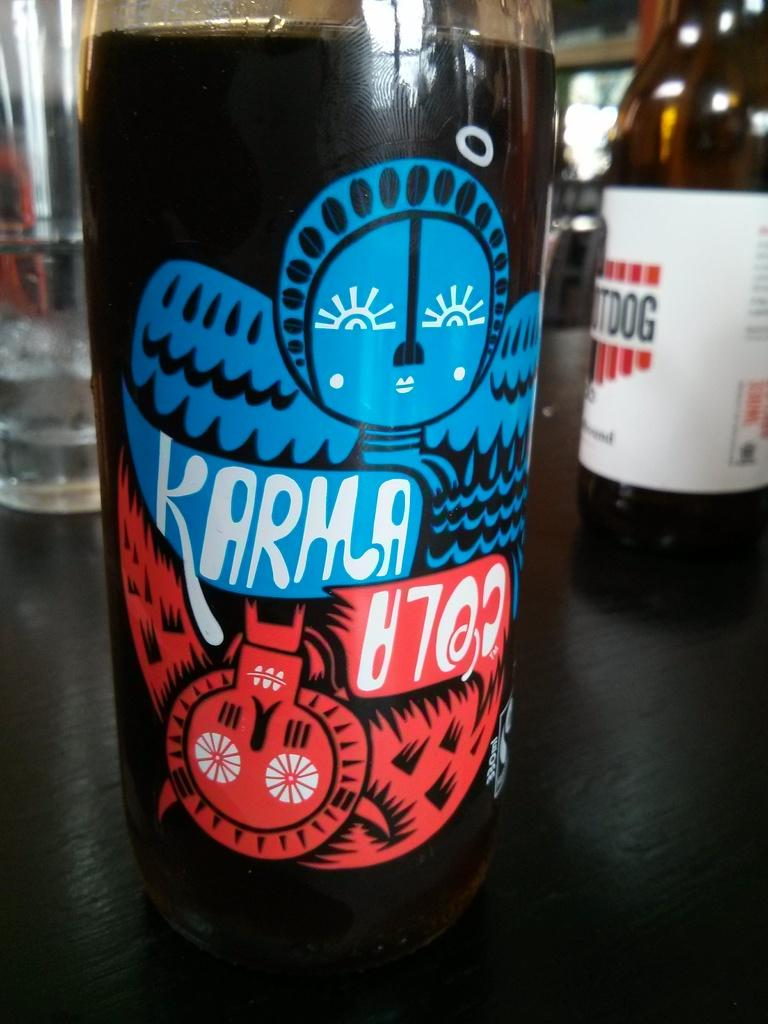What is inside the glass bottle in the image? There is a liquid inside the glass bottle in the image. Where is the glass bottle located? The glass bottle is on a table. What other glass object can be seen in the background of the image? There is a glass on the same table in the background. What other bottle can be seen in the background of the image? There is another bottle on the same table in the background. What type of art is displayed on the glass bottle in the image? There is no art displayed on the glass bottle in the image; it is a plain glass bottle with a liquid inside. 